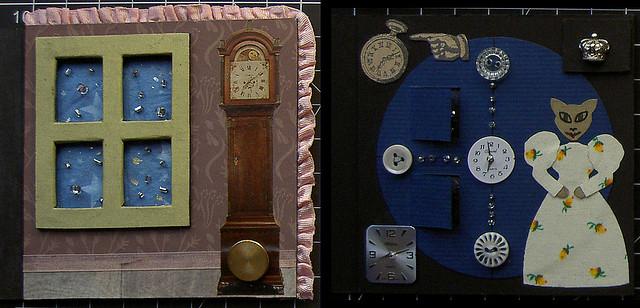What letter is next to the cat?
Keep it brief. No letter. What do the clocks say?
Concise answer only. Different times. Is there a snowflake?
Short answer required. No. What design style does this represent?
Concise answer only. Abstract. Is the clock on the right covered with a glass frame??
Short answer required. No. How many clocks are in the picture?
Write a very short answer. 4. What is cat wearing?
Short answer required. Dress. What time is on the clock?
Write a very short answer. 7. How many circles?
Keep it brief. 6. What style of art is this?
Keep it brief. Drama art. 